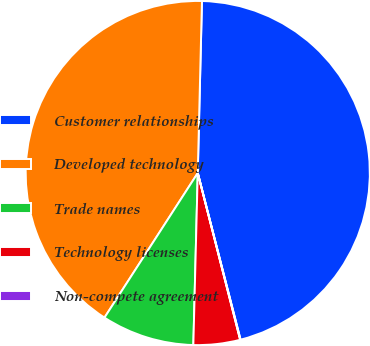<chart> <loc_0><loc_0><loc_500><loc_500><pie_chart><fcel>Customer relationships<fcel>Developed technology<fcel>Trade names<fcel>Technology licenses<fcel>Non-compete agreement<nl><fcel>45.61%<fcel>41.27%<fcel>8.71%<fcel>4.37%<fcel>0.04%<nl></chart> 